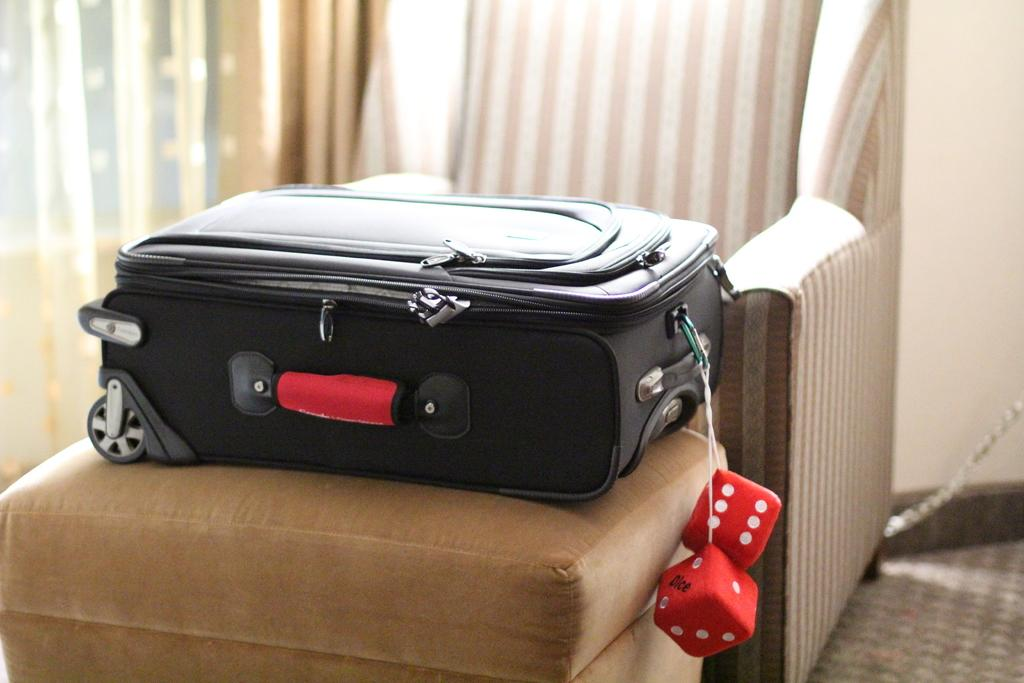What is the color of the suitcase in the image? The suitcase in the image is black. Where is the suitcase placed? The suitcase is placed on a brown color sofa. What decorations are attached to the suitcase? Two dices are attached to the suitcase. What can be seen in the background of the image? There is a curtain and a black sofa in the background of the image. What type of yak can be seen grazing on the plate in the image? There is no yak or plate present in the image. How does the heat affect the suitcase in the image? The image does not provide any information about the temperature or heat, so it cannot be determined how it affects the suitcase. 